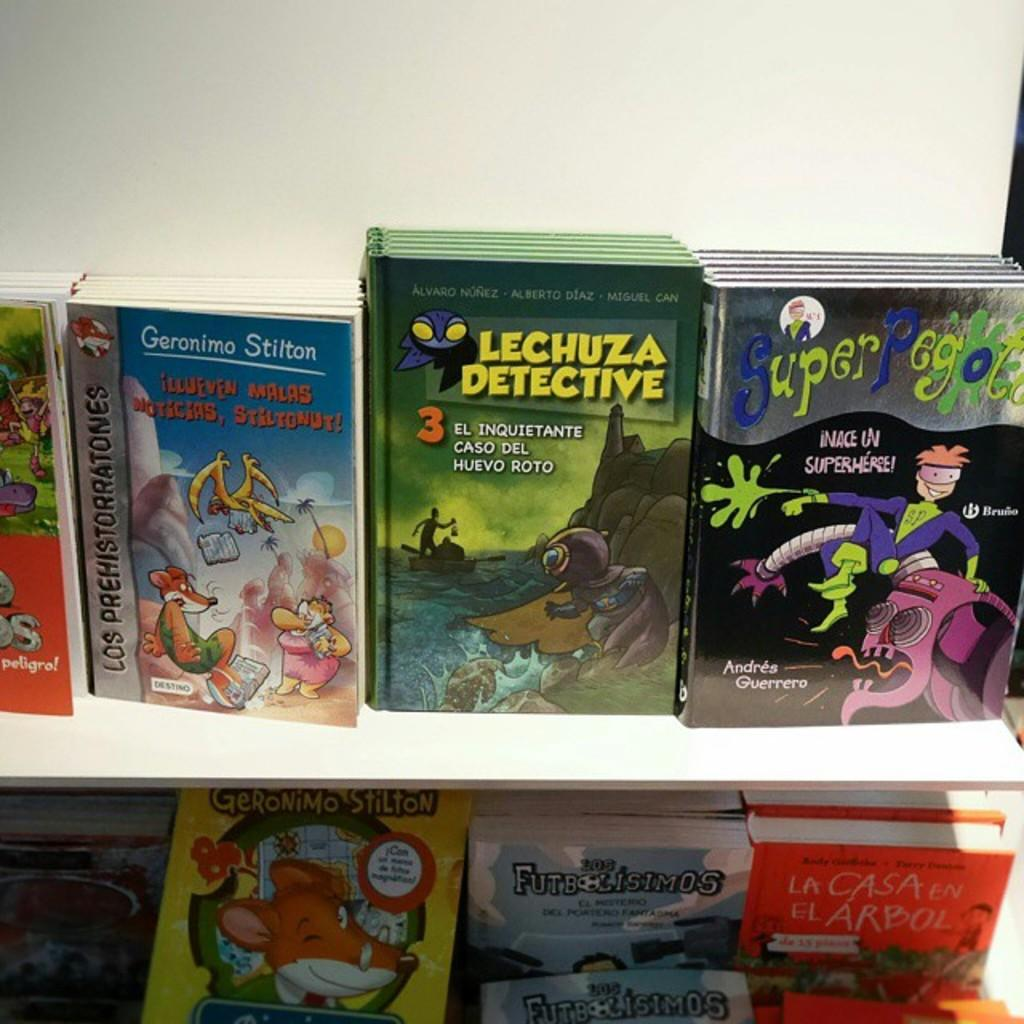Provide a one-sentence caption for the provided image. A display of children's books includes "Lechuza Detective. 